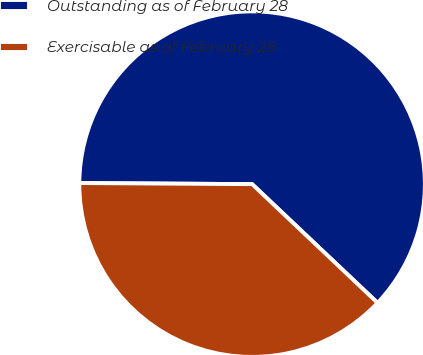Convert chart to OTSL. <chart><loc_0><loc_0><loc_500><loc_500><pie_chart><fcel>Outstanding as of February 28<fcel>Exercisable as of February 28<nl><fcel>61.96%<fcel>38.04%<nl></chart> 